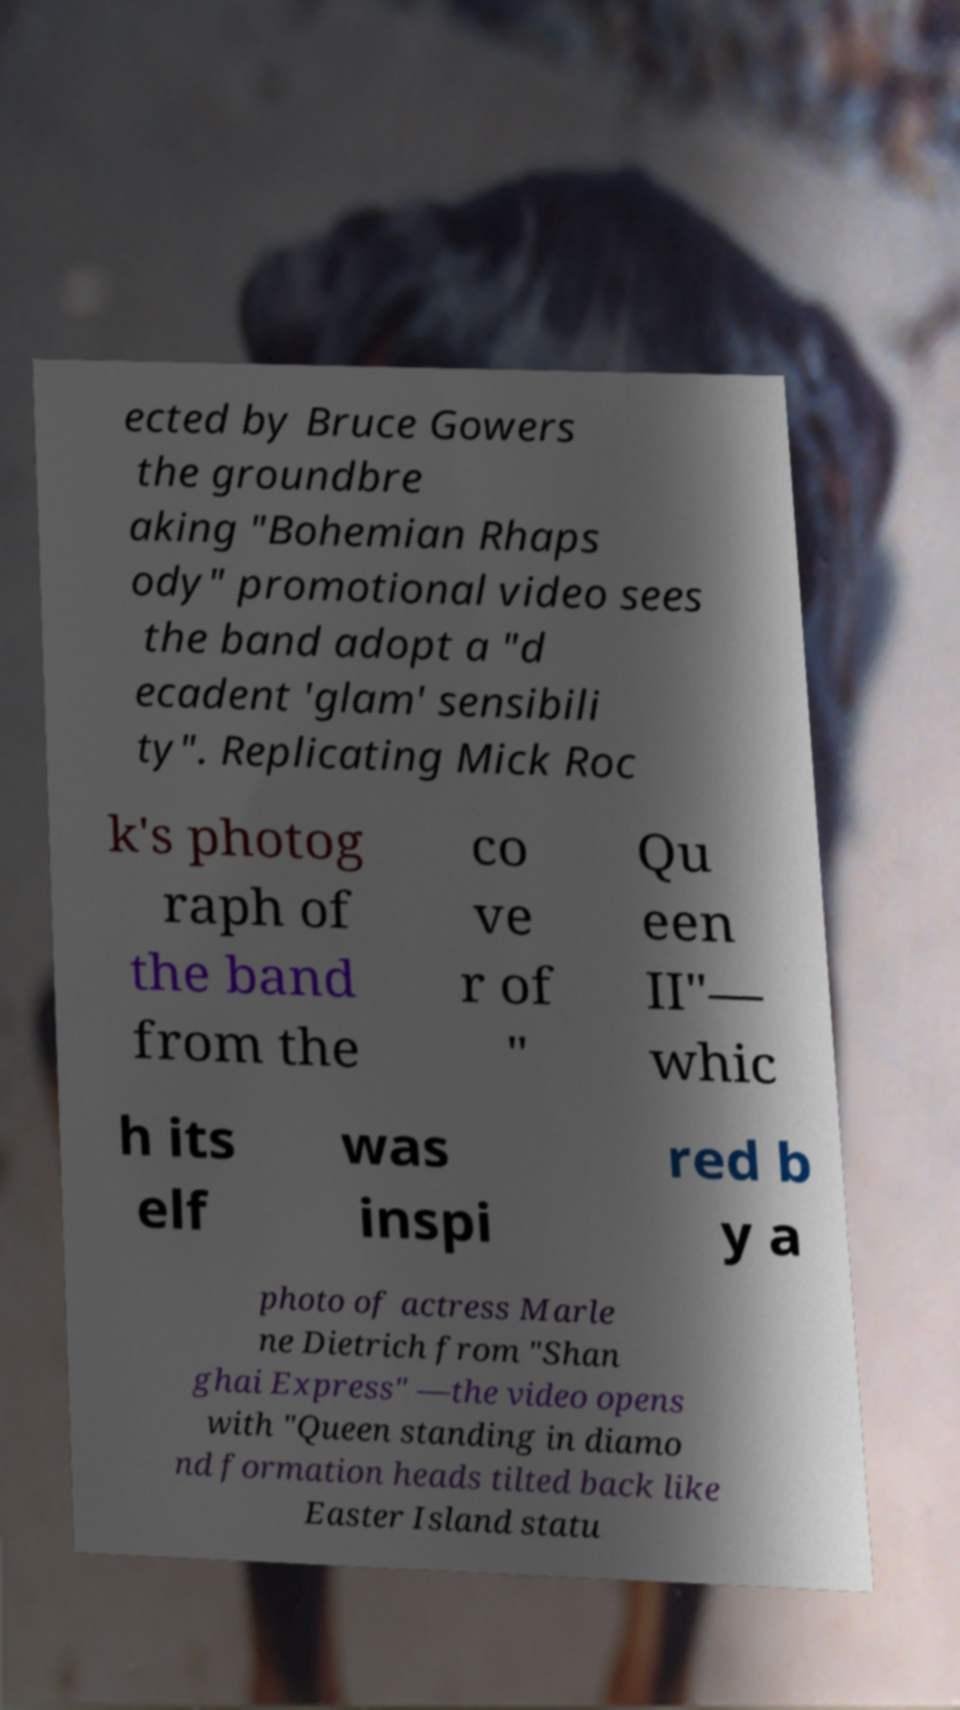Can you read and provide the text displayed in the image?This photo seems to have some interesting text. Can you extract and type it out for me? ected by Bruce Gowers the groundbre aking "Bohemian Rhaps ody" promotional video sees the band adopt a "d ecadent 'glam' sensibili ty". Replicating Mick Roc k's photog raph of the band from the co ve r of " Qu een II"— whic h its elf was inspi red b y a photo of actress Marle ne Dietrich from "Shan ghai Express" —the video opens with "Queen standing in diamo nd formation heads tilted back like Easter Island statu 